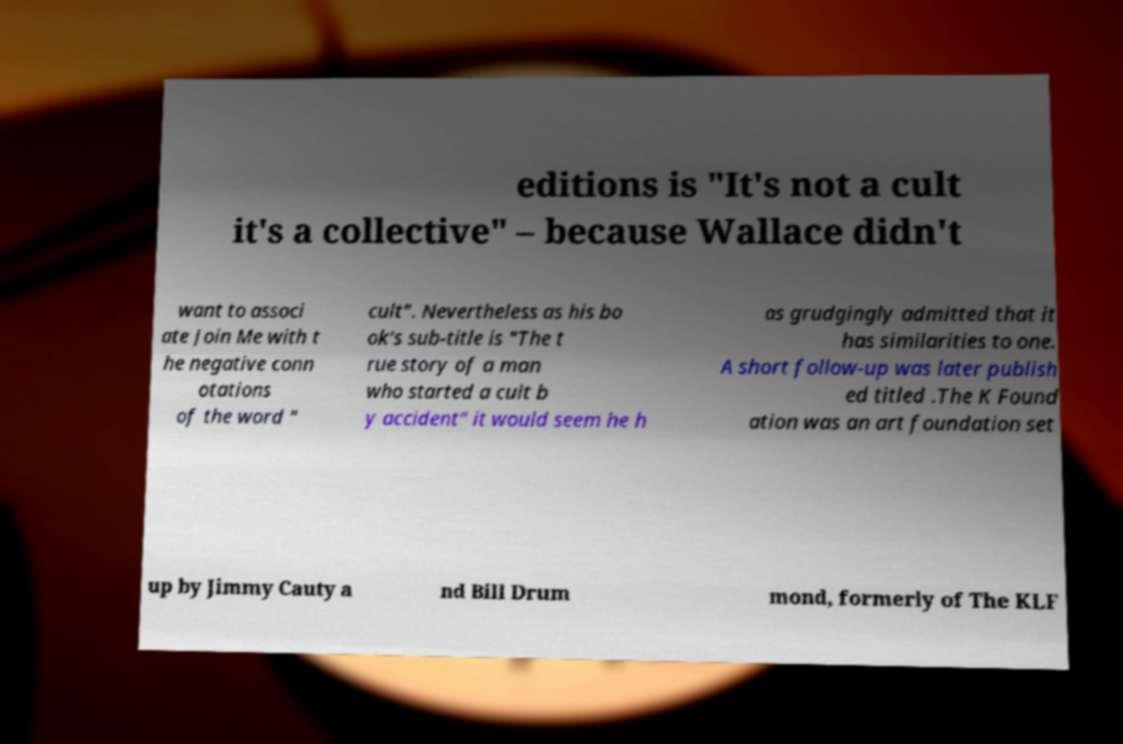Could you extract and type out the text from this image? editions is "It's not a cult it's a collective" – because Wallace didn't want to associ ate Join Me with t he negative conn otations of the word " cult". Nevertheless as his bo ok's sub-title is "The t rue story of a man who started a cult b y accident" it would seem he h as grudgingly admitted that it has similarities to one. A short follow-up was later publish ed titled .The K Found ation was an art foundation set up by Jimmy Cauty a nd Bill Drum mond, formerly of The KLF 